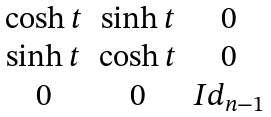Convert formula to latex. <formula><loc_0><loc_0><loc_500><loc_500>\begin{matrix} \cosh t & \sinh t & 0 \\ \sinh t & \cosh t & 0 \\ 0 & 0 & I d _ { n - 1 } \\ \end{matrix}</formula> 